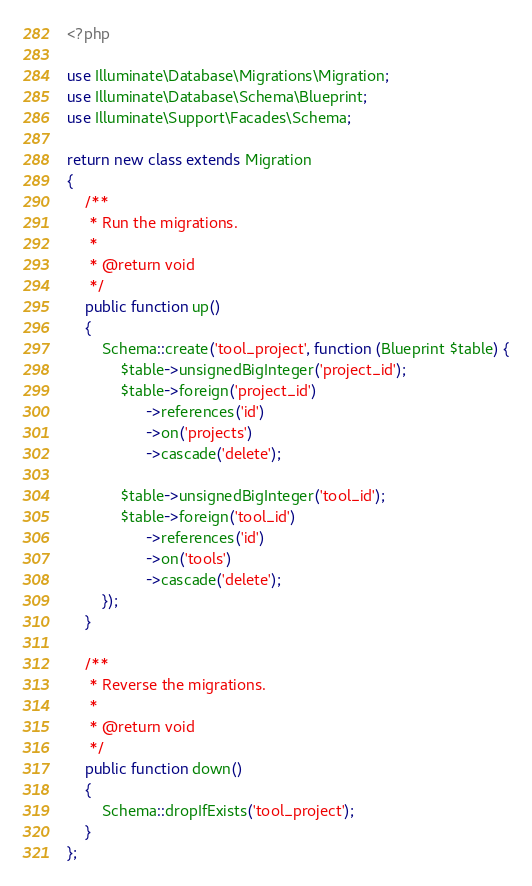Convert code to text. <code><loc_0><loc_0><loc_500><loc_500><_PHP_><?php

use Illuminate\Database\Migrations\Migration;
use Illuminate\Database\Schema\Blueprint;
use Illuminate\Support\Facades\Schema;

return new class extends Migration
{
    /**
     * Run the migrations.
     *
     * @return void
     */
    public function up()
    {
        Schema::create('tool_project', function (Blueprint $table) {
            $table->unsignedBigInteger('project_id');
            $table->foreign('project_id')
                  ->references('id')
                  ->on('projects')
                  ->cascade('delete');

            $table->unsignedBigInteger('tool_id');
            $table->foreign('tool_id')
                  ->references('id')
                  ->on('tools')
                  ->cascade('delete');
        });
    }

    /**
     * Reverse the migrations.
     *
     * @return void
     */
    public function down()
    {
        Schema::dropIfExists('tool_project');
    }
};
</code> 